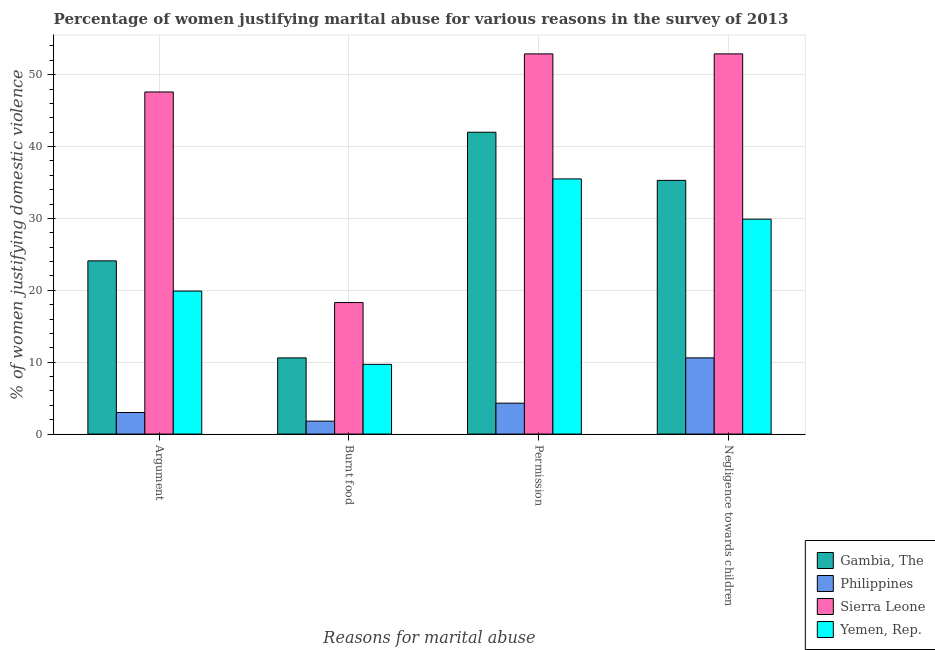Are the number of bars per tick equal to the number of legend labels?
Your answer should be very brief. Yes. Are the number of bars on each tick of the X-axis equal?
Keep it short and to the point. Yes. How many bars are there on the 3rd tick from the left?
Provide a short and direct response. 4. How many bars are there on the 4th tick from the right?
Make the answer very short. 4. What is the label of the 1st group of bars from the left?
Make the answer very short. Argument. Across all countries, what is the maximum percentage of women justifying abuse for burning food?
Make the answer very short. 18.3. In which country was the percentage of women justifying abuse for going without permission maximum?
Make the answer very short. Sierra Leone. What is the total percentage of women justifying abuse in the case of an argument in the graph?
Your response must be concise. 94.6. What is the difference between the percentage of women justifying abuse for going without permission in Gambia, The and the percentage of women justifying abuse for burning food in Sierra Leone?
Your answer should be compact. 23.7. What is the average percentage of women justifying abuse for going without permission per country?
Ensure brevity in your answer.  33.67. What is the difference between the percentage of women justifying abuse for burning food and percentage of women justifying abuse for going without permission in Gambia, The?
Keep it short and to the point. -31.4. In how many countries, is the percentage of women justifying abuse for going without permission greater than 48 %?
Offer a terse response. 1. What is the ratio of the percentage of women justifying abuse in the case of an argument in Philippines to that in Yemen, Rep.?
Make the answer very short. 0.15. Is the percentage of women justifying abuse for showing negligence towards children in Sierra Leone less than that in Gambia, The?
Your response must be concise. No. What is the difference between the highest and the second highest percentage of women justifying abuse for going without permission?
Provide a succinct answer. 10.9. What is the difference between the highest and the lowest percentage of women justifying abuse in the case of an argument?
Offer a terse response. 44.6. In how many countries, is the percentage of women justifying abuse for burning food greater than the average percentage of women justifying abuse for burning food taken over all countries?
Ensure brevity in your answer.  2. Is the sum of the percentage of women justifying abuse for going without permission in Sierra Leone and Philippines greater than the maximum percentage of women justifying abuse in the case of an argument across all countries?
Your response must be concise. Yes. What does the 4th bar from the right in Burnt food represents?
Your response must be concise. Gambia, The. How many countries are there in the graph?
Your answer should be very brief. 4. What is the difference between two consecutive major ticks on the Y-axis?
Provide a short and direct response. 10. Are the values on the major ticks of Y-axis written in scientific E-notation?
Ensure brevity in your answer.  No. Does the graph contain any zero values?
Offer a very short reply. No. How are the legend labels stacked?
Your answer should be compact. Vertical. What is the title of the graph?
Provide a short and direct response. Percentage of women justifying marital abuse for various reasons in the survey of 2013. What is the label or title of the X-axis?
Ensure brevity in your answer.  Reasons for marital abuse. What is the label or title of the Y-axis?
Your response must be concise. % of women justifying domestic violence. What is the % of women justifying domestic violence in Gambia, The in Argument?
Give a very brief answer. 24.1. What is the % of women justifying domestic violence of Sierra Leone in Argument?
Make the answer very short. 47.6. What is the % of women justifying domestic violence in Philippines in Burnt food?
Your answer should be very brief. 1.8. What is the % of women justifying domestic violence in Sierra Leone in Burnt food?
Make the answer very short. 18.3. What is the % of women justifying domestic violence in Philippines in Permission?
Offer a very short reply. 4.3. What is the % of women justifying domestic violence of Sierra Leone in Permission?
Keep it short and to the point. 52.9. What is the % of women justifying domestic violence of Yemen, Rep. in Permission?
Provide a short and direct response. 35.5. What is the % of women justifying domestic violence in Gambia, The in Negligence towards children?
Make the answer very short. 35.3. What is the % of women justifying domestic violence of Philippines in Negligence towards children?
Give a very brief answer. 10.6. What is the % of women justifying domestic violence in Sierra Leone in Negligence towards children?
Provide a succinct answer. 52.9. What is the % of women justifying domestic violence in Yemen, Rep. in Negligence towards children?
Ensure brevity in your answer.  29.9. Across all Reasons for marital abuse, what is the maximum % of women justifying domestic violence in Philippines?
Your answer should be compact. 10.6. Across all Reasons for marital abuse, what is the maximum % of women justifying domestic violence of Sierra Leone?
Make the answer very short. 52.9. Across all Reasons for marital abuse, what is the maximum % of women justifying domestic violence of Yemen, Rep.?
Keep it short and to the point. 35.5. Across all Reasons for marital abuse, what is the minimum % of women justifying domestic violence of Gambia, The?
Offer a terse response. 10.6. Across all Reasons for marital abuse, what is the minimum % of women justifying domestic violence in Sierra Leone?
Give a very brief answer. 18.3. What is the total % of women justifying domestic violence in Gambia, The in the graph?
Provide a short and direct response. 112. What is the total % of women justifying domestic violence in Philippines in the graph?
Your answer should be compact. 19.7. What is the total % of women justifying domestic violence of Sierra Leone in the graph?
Provide a short and direct response. 171.7. What is the total % of women justifying domestic violence in Yemen, Rep. in the graph?
Make the answer very short. 95. What is the difference between the % of women justifying domestic violence in Gambia, The in Argument and that in Burnt food?
Give a very brief answer. 13.5. What is the difference between the % of women justifying domestic violence in Sierra Leone in Argument and that in Burnt food?
Give a very brief answer. 29.3. What is the difference between the % of women justifying domestic violence in Yemen, Rep. in Argument and that in Burnt food?
Your answer should be compact. 10.2. What is the difference between the % of women justifying domestic violence in Gambia, The in Argument and that in Permission?
Give a very brief answer. -17.9. What is the difference between the % of women justifying domestic violence of Yemen, Rep. in Argument and that in Permission?
Offer a very short reply. -15.6. What is the difference between the % of women justifying domestic violence of Gambia, The in Argument and that in Negligence towards children?
Keep it short and to the point. -11.2. What is the difference between the % of women justifying domestic violence in Philippines in Argument and that in Negligence towards children?
Provide a short and direct response. -7.6. What is the difference between the % of women justifying domestic violence of Yemen, Rep. in Argument and that in Negligence towards children?
Offer a very short reply. -10. What is the difference between the % of women justifying domestic violence of Gambia, The in Burnt food and that in Permission?
Your response must be concise. -31.4. What is the difference between the % of women justifying domestic violence of Philippines in Burnt food and that in Permission?
Your response must be concise. -2.5. What is the difference between the % of women justifying domestic violence in Sierra Leone in Burnt food and that in Permission?
Offer a terse response. -34.6. What is the difference between the % of women justifying domestic violence of Yemen, Rep. in Burnt food and that in Permission?
Make the answer very short. -25.8. What is the difference between the % of women justifying domestic violence of Gambia, The in Burnt food and that in Negligence towards children?
Offer a very short reply. -24.7. What is the difference between the % of women justifying domestic violence of Philippines in Burnt food and that in Negligence towards children?
Keep it short and to the point. -8.8. What is the difference between the % of women justifying domestic violence in Sierra Leone in Burnt food and that in Negligence towards children?
Your response must be concise. -34.6. What is the difference between the % of women justifying domestic violence in Yemen, Rep. in Burnt food and that in Negligence towards children?
Keep it short and to the point. -20.2. What is the difference between the % of women justifying domestic violence in Philippines in Permission and that in Negligence towards children?
Your answer should be very brief. -6.3. What is the difference between the % of women justifying domestic violence of Sierra Leone in Permission and that in Negligence towards children?
Your response must be concise. 0. What is the difference between the % of women justifying domestic violence of Gambia, The in Argument and the % of women justifying domestic violence of Philippines in Burnt food?
Give a very brief answer. 22.3. What is the difference between the % of women justifying domestic violence of Gambia, The in Argument and the % of women justifying domestic violence of Sierra Leone in Burnt food?
Your response must be concise. 5.8. What is the difference between the % of women justifying domestic violence in Philippines in Argument and the % of women justifying domestic violence in Sierra Leone in Burnt food?
Offer a very short reply. -15.3. What is the difference between the % of women justifying domestic violence of Philippines in Argument and the % of women justifying domestic violence of Yemen, Rep. in Burnt food?
Provide a short and direct response. -6.7. What is the difference between the % of women justifying domestic violence in Sierra Leone in Argument and the % of women justifying domestic violence in Yemen, Rep. in Burnt food?
Your answer should be very brief. 37.9. What is the difference between the % of women justifying domestic violence of Gambia, The in Argument and the % of women justifying domestic violence of Philippines in Permission?
Keep it short and to the point. 19.8. What is the difference between the % of women justifying domestic violence of Gambia, The in Argument and the % of women justifying domestic violence of Sierra Leone in Permission?
Your answer should be compact. -28.8. What is the difference between the % of women justifying domestic violence of Philippines in Argument and the % of women justifying domestic violence of Sierra Leone in Permission?
Offer a terse response. -49.9. What is the difference between the % of women justifying domestic violence of Philippines in Argument and the % of women justifying domestic violence of Yemen, Rep. in Permission?
Keep it short and to the point. -32.5. What is the difference between the % of women justifying domestic violence in Gambia, The in Argument and the % of women justifying domestic violence in Sierra Leone in Negligence towards children?
Your answer should be very brief. -28.8. What is the difference between the % of women justifying domestic violence of Philippines in Argument and the % of women justifying domestic violence of Sierra Leone in Negligence towards children?
Offer a terse response. -49.9. What is the difference between the % of women justifying domestic violence of Philippines in Argument and the % of women justifying domestic violence of Yemen, Rep. in Negligence towards children?
Provide a short and direct response. -26.9. What is the difference between the % of women justifying domestic violence in Gambia, The in Burnt food and the % of women justifying domestic violence in Sierra Leone in Permission?
Your answer should be compact. -42.3. What is the difference between the % of women justifying domestic violence of Gambia, The in Burnt food and the % of women justifying domestic violence of Yemen, Rep. in Permission?
Offer a very short reply. -24.9. What is the difference between the % of women justifying domestic violence in Philippines in Burnt food and the % of women justifying domestic violence in Sierra Leone in Permission?
Your answer should be very brief. -51.1. What is the difference between the % of women justifying domestic violence of Philippines in Burnt food and the % of women justifying domestic violence of Yemen, Rep. in Permission?
Offer a very short reply. -33.7. What is the difference between the % of women justifying domestic violence of Sierra Leone in Burnt food and the % of women justifying domestic violence of Yemen, Rep. in Permission?
Provide a succinct answer. -17.2. What is the difference between the % of women justifying domestic violence in Gambia, The in Burnt food and the % of women justifying domestic violence in Philippines in Negligence towards children?
Ensure brevity in your answer.  0. What is the difference between the % of women justifying domestic violence of Gambia, The in Burnt food and the % of women justifying domestic violence of Sierra Leone in Negligence towards children?
Provide a short and direct response. -42.3. What is the difference between the % of women justifying domestic violence of Gambia, The in Burnt food and the % of women justifying domestic violence of Yemen, Rep. in Negligence towards children?
Your answer should be compact. -19.3. What is the difference between the % of women justifying domestic violence of Philippines in Burnt food and the % of women justifying domestic violence of Sierra Leone in Negligence towards children?
Offer a very short reply. -51.1. What is the difference between the % of women justifying domestic violence of Philippines in Burnt food and the % of women justifying domestic violence of Yemen, Rep. in Negligence towards children?
Keep it short and to the point. -28.1. What is the difference between the % of women justifying domestic violence of Gambia, The in Permission and the % of women justifying domestic violence of Philippines in Negligence towards children?
Provide a succinct answer. 31.4. What is the difference between the % of women justifying domestic violence of Philippines in Permission and the % of women justifying domestic violence of Sierra Leone in Negligence towards children?
Offer a terse response. -48.6. What is the difference between the % of women justifying domestic violence in Philippines in Permission and the % of women justifying domestic violence in Yemen, Rep. in Negligence towards children?
Provide a succinct answer. -25.6. What is the average % of women justifying domestic violence in Gambia, The per Reasons for marital abuse?
Make the answer very short. 28. What is the average % of women justifying domestic violence in Philippines per Reasons for marital abuse?
Your response must be concise. 4.92. What is the average % of women justifying domestic violence of Sierra Leone per Reasons for marital abuse?
Your answer should be compact. 42.92. What is the average % of women justifying domestic violence of Yemen, Rep. per Reasons for marital abuse?
Give a very brief answer. 23.75. What is the difference between the % of women justifying domestic violence of Gambia, The and % of women justifying domestic violence of Philippines in Argument?
Provide a short and direct response. 21.1. What is the difference between the % of women justifying domestic violence of Gambia, The and % of women justifying domestic violence of Sierra Leone in Argument?
Provide a short and direct response. -23.5. What is the difference between the % of women justifying domestic violence in Gambia, The and % of women justifying domestic violence in Yemen, Rep. in Argument?
Offer a terse response. 4.2. What is the difference between the % of women justifying domestic violence in Philippines and % of women justifying domestic violence in Sierra Leone in Argument?
Offer a very short reply. -44.6. What is the difference between the % of women justifying domestic violence of Philippines and % of women justifying domestic violence of Yemen, Rep. in Argument?
Your answer should be very brief. -16.9. What is the difference between the % of women justifying domestic violence in Sierra Leone and % of women justifying domestic violence in Yemen, Rep. in Argument?
Make the answer very short. 27.7. What is the difference between the % of women justifying domestic violence in Philippines and % of women justifying domestic violence in Sierra Leone in Burnt food?
Ensure brevity in your answer.  -16.5. What is the difference between the % of women justifying domestic violence in Philippines and % of women justifying domestic violence in Yemen, Rep. in Burnt food?
Give a very brief answer. -7.9. What is the difference between the % of women justifying domestic violence in Gambia, The and % of women justifying domestic violence in Philippines in Permission?
Your answer should be very brief. 37.7. What is the difference between the % of women justifying domestic violence in Gambia, The and % of women justifying domestic violence in Sierra Leone in Permission?
Your response must be concise. -10.9. What is the difference between the % of women justifying domestic violence in Philippines and % of women justifying domestic violence in Sierra Leone in Permission?
Keep it short and to the point. -48.6. What is the difference between the % of women justifying domestic violence in Philippines and % of women justifying domestic violence in Yemen, Rep. in Permission?
Provide a succinct answer. -31.2. What is the difference between the % of women justifying domestic violence of Gambia, The and % of women justifying domestic violence of Philippines in Negligence towards children?
Your answer should be compact. 24.7. What is the difference between the % of women justifying domestic violence of Gambia, The and % of women justifying domestic violence of Sierra Leone in Negligence towards children?
Ensure brevity in your answer.  -17.6. What is the difference between the % of women justifying domestic violence in Gambia, The and % of women justifying domestic violence in Yemen, Rep. in Negligence towards children?
Ensure brevity in your answer.  5.4. What is the difference between the % of women justifying domestic violence in Philippines and % of women justifying domestic violence in Sierra Leone in Negligence towards children?
Give a very brief answer. -42.3. What is the difference between the % of women justifying domestic violence in Philippines and % of women justifying domestic violence in Yemen, Rep. in Negligence towards children?
Your answer should be compact. -19.3. What is the difference between the % of women justifying domestic violence in Sierra Leone and % of women justifying domestic violence in Yemen, Rep. in Negligence towards children?
Provide a short and direct response. 23. What is the ratio of the % of women justifying domestic violence in Gambia, The in Argument to that in Burnt food?
Make the answer very short. 2.27. What is the ratio of the % of women justifying domestic violence in Philippines in Argument to that in Burnt food?
Offer a very short reply. 1.67. What is the ratio of the % of women justifying domestic violence of Sierra Leone in Argument to that in Burnt food?
Give a very brief answer. 2.6. What is the ratio of the % of women justifying domestic violence in Yemen, Rep. in Argument to that in Burnt food?
Provide a short and direct response. 2.05. What is the ratio of the % of women justifying domestic violence in Gambia, The in Argument to that in Permission?
Provide a short and direct response. 0.57. What is the ratio of the % of women justifying domestic violence in Philippines in Argument to that in Permission?
Provide a succinct answer. 0.7. What is the ratio of the % of women justifying domestic violence of Sierra Leone in Argument to that in Permission?
Provide a succinct answer. 0.9. What is the ratio of the % of women justifying domestic violence in Yemen, Rep. in Argument to that in Permission?
Offer a very short reply. 0.56. What is the ratio of the % of women justifying domestic violence in Gambia, The in Argument to that in Negligence towards children?
Ensure brevity in your answer.  0.68. What is the ratio of the % of women justifying domestic violence in Philippines in Argument to that in Negligence towards children?
Make the answer very short. 0.28. What is the ratio of the % of women justifying domestic violence in Sierra Leone in Argument to that in Negligence towards children?
Provide a short and direct response. 0.9. What is the ratio of the % of women justifying domestic violence in Yemen, Rep. in Argument to that in Negligence towards children?
Your response must be concise. 0.67. What is the ratio of the % of women justifying domestic violence in Gambia, The in Burnt food to that in Permission?
Provide a succinct answer. 0.25. What is the ratio of the % of women justifying domestic violence of Philippines in Burnt food to that in Permission?
Your response must be concise. 0.42. What is the ratio of the % of women justifying domestic violence in Sierra Leone in Burnt food to that in Permission?
Give a very brief answer. 0.35. What is the ratio of the % of women justifying domestic violence in Yemen, Rep. in Burnt food to that in Permission?
Offer a terse response. 0.27. What is the ratio of the % of women justifying domestic violence in Gambia, The in Burnt food to that in Negligence towards children?
Provide a succinct answer. 0.3. What is the ratio of the % of women justifying domestic violence in Philippines in Burnt food to that in Negligence towards children?
Provide a succinct answer. 0.17. What is the ratio of the % of women justifying domestic violence in Sierra Leone in Burnt food to that in Negligence towards children?
Your response must be concise. 0.35. What is the ratio of the % of women justifying domestic violence of Yemen, Rep. in Burnt food to that in Negligence towards children?
Make the answer very short. 0.32. What is the ratio of the % of women justifying domestic violence of Gambia, The in Permission to that in Negligence towards children?
Offer a terse response. 1.19. What is the ratio of the % of women justifying domestic violence of Philippines in Permission to that in Negligence towards children?
Your response must be concise. 0.41. What is the ratio of the % of women justifying domestic violence of Yemen, Rep. in Permission to that in Negligence towards children?
Provide a short and direct response. 1.19. What is the difference between the highest and the second highest % of women justifying domestic violence of Gambia, The?
Provide a short and direct response. 6.7. What is the difference between the highest and the lowest % of women justifying domestic violence of Gambia, The?
Ensure brevity in your answer.  31.4. What is the difference between the highest and the lowest % of women justifying domestic violence of Sierra Leone?
Make the answer very short. 34.6. What is the difference between the highest and the lowest % of women justifying domestic violence in Yemen, Rep.?
Your answer should be very brief. 25.8. 